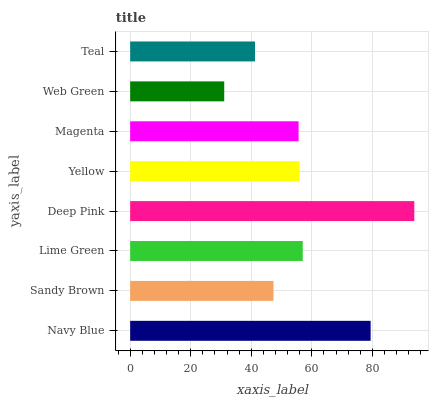Is Web Green the minimum?
Answer yes or no. Yes. Is Deep Pink the maximum?
Answer yes or no. Yes. Is Sandy Brown the minimum?
Answer yes or no. No. Is Sandy Brown the maximum?
Answer yes or no. No. Is Navy Blue greater than Sandy Brown?
Answer yes or no. Yes. Is Sandy Brown less than Navy Blue?
Answer yes or no. Yes. Is Sandy Brown greater than Navy Blue?
Answer yes or no. No. Is Navy Blue less than Sandy Brown?
Answer yes or no. No. Is Yellow the high median?
Answer yes or no. Yes. Is Magenta the low median?
Answer yes or no. Yes. Is Sandy Brown the high median?
Answer yes or no. No. Is Teal the low median?
Answer yes or no. No. 